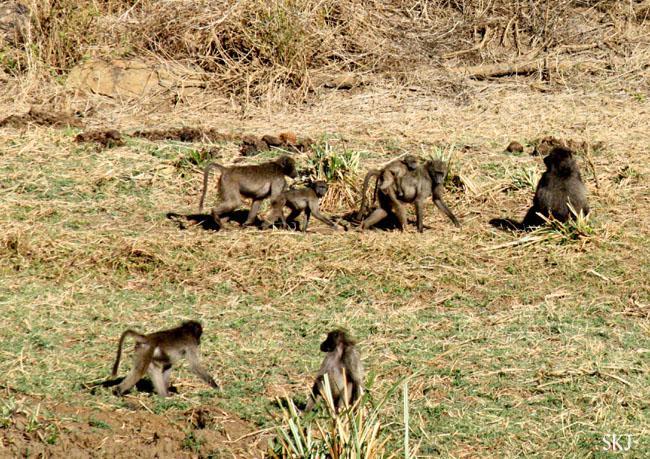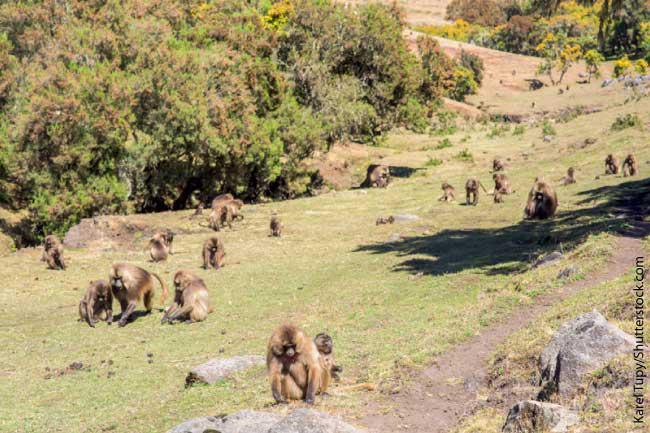The first image is the image on the left, the second image is the image on the right. Given the left and right images, does the statement "There are less than ten monkeys in the image on the right." hold true? Answer yes or no. No. 